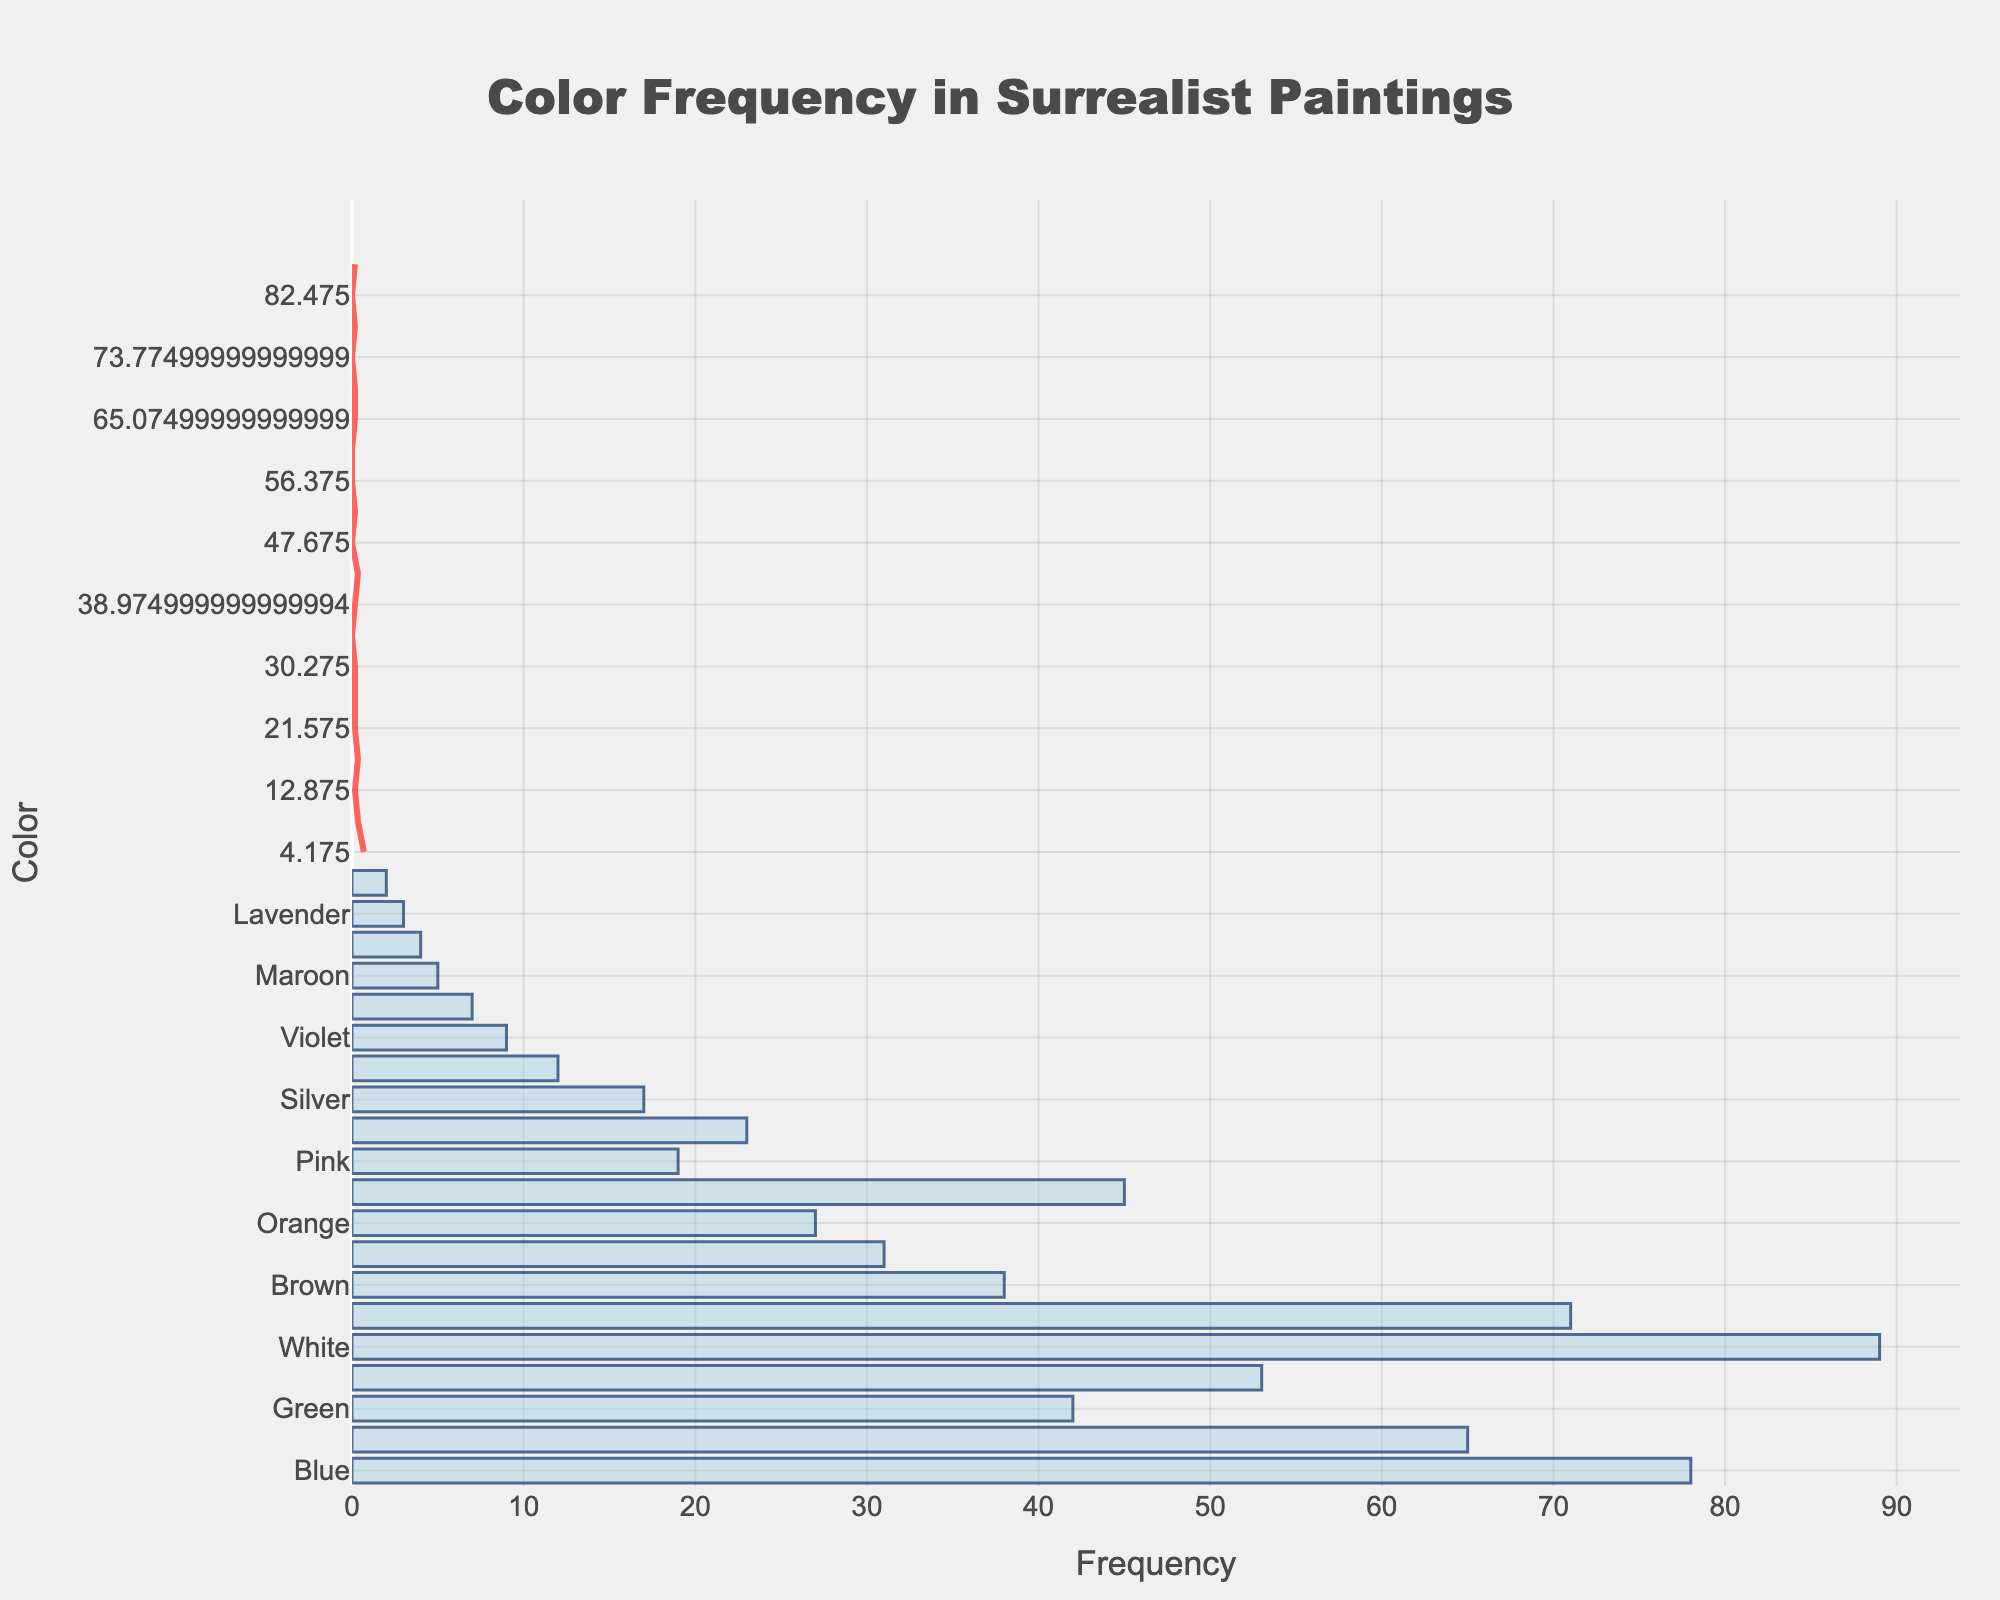What's the most frequently used color mentioned in the figure? The most frequently used color is represented by the highest bar. The bar for "White" has the greatest height, indicating the highest frequency.
Answer: White What color has the least usage according to the figure? The color with the least usage will have the smallest bar. The smallest bar corresponds to "Magenta".
Answer: Magenta How many colors have a frequency of more than 50? By counting the bars that extend beyond the 50 mark on the frequency axis, we find that the colors "Blue", "Red", "White", "Black", and "Yellow" surpass this threshold.
Answer: 5 Which has a higher frequency: "Green" or "Gray"? By comparing the bars for "Green" and "Gray", we see that "Green" has a height of 42, while "Gray" has a height of 45, so "Gray" is higher.
Answer: Gray What's the average frequency of the top 3 most frequently used colors? First, identify the top 3 colors by frequency: "White" (89), "Blue" (78), and "Black" (71). Sum these frequencies (89 + 78 + 71 = 238) and divide by 3 to get the average. 238/3 = 79.33
Answer: 79.33 What's the difference in frequency between "Pink" and "Gold"? "Pink" has a frequency of 19, and "Gold" has a frequency of 23. The difference is calculated as 23 - 19.
Answer: 4 Are more colors used frequently with a frequency of less than 20 or more than 50? Count the colors with frequencies less than 20 ("Pink", "Silver", "Turquoise", "Violet", "Indigo", "Maroon", "Olive", "Lavender", "Magenta") which total to 9, and those with more than 50 ("Blue", "Red", "White", "Black", "Yellow") total to 5.
Answer: Less than 20 What does the smooth line over the histogram represent? The smooth line is a KDE (Kernel Density Estimate) curve, showing the density of frequencies while smoothing out variations.
Answer: KDE Which two colors have the closest frequency usage? Compare frequencies to find the smallest difference. "Yellow" has 53 and "Gray" has 45, with a difference of 8, which is the smallest.
Answer: Yellow and Gray Is the density of color usage highest where the histogram bars are tallest or shortest? The KDE curve should peak where bars are tallest, indicating the density is highest around the highest frequency values. The tallest bars are around "White", "Blue", and "Black".
Answer: Tallest 